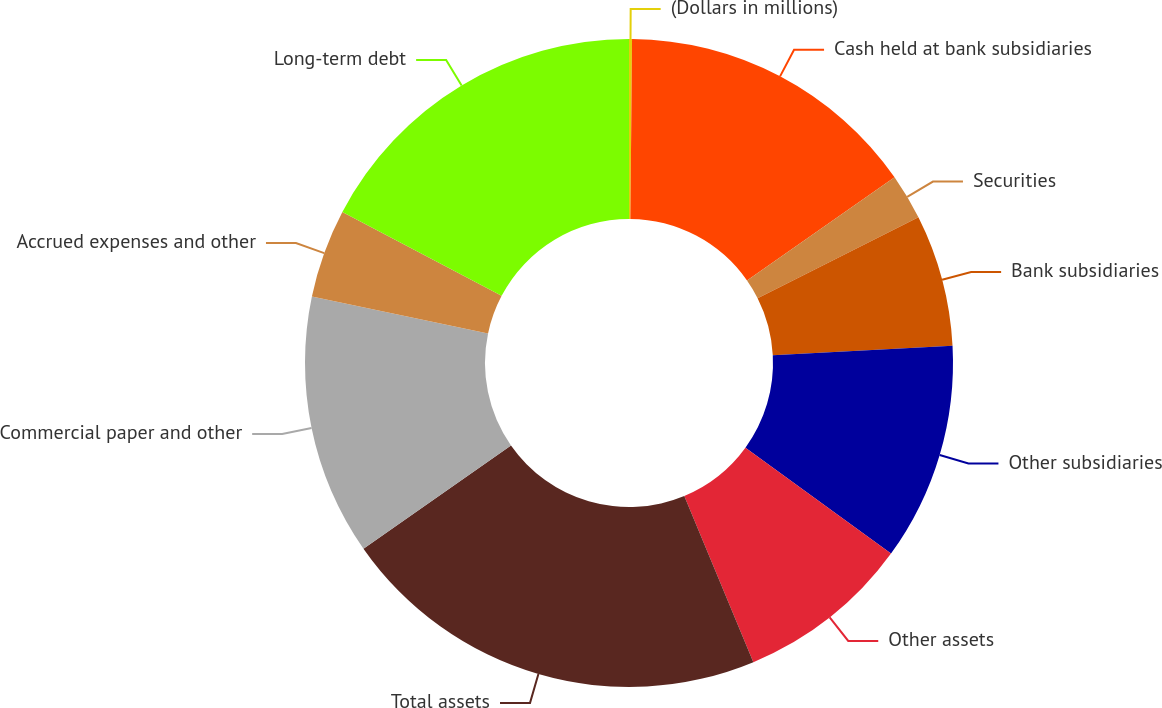Convert chart to OTSL. <chart><loc_0><loc_0><loc_500><loc_500><pie_chart><fcel>(Dollars in millions)<fcel>Cash held at bank subsidiaries<fcel>Securities<fcel>Bank subsidiaries<fcel>Other subsidiaries<fcel>Other assets<fcel>Total assets<fcel>Commercial paper and other<fcel>Accrued expenses and other<fcel>Long-term debt<nl><fcel>0.15%<fcel>15.14%<fcel>2.29%<fcel>6.57%<fcel>10.86%<fcel>8.72%<fcel>21.56%<fcel>13.0%<fcel>4.43%<fcel>17.28%<nl></chart> 